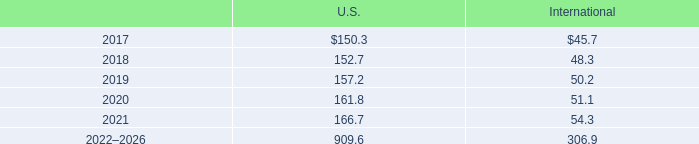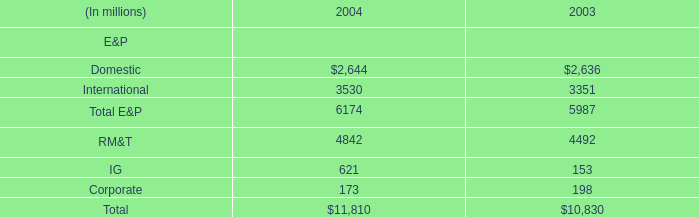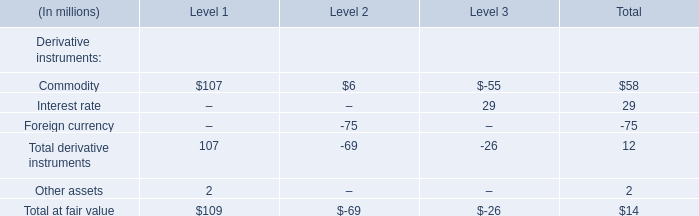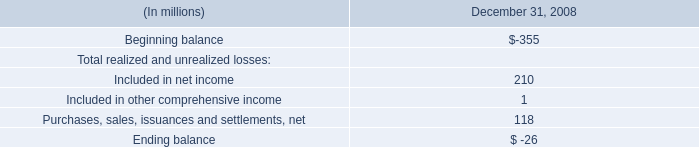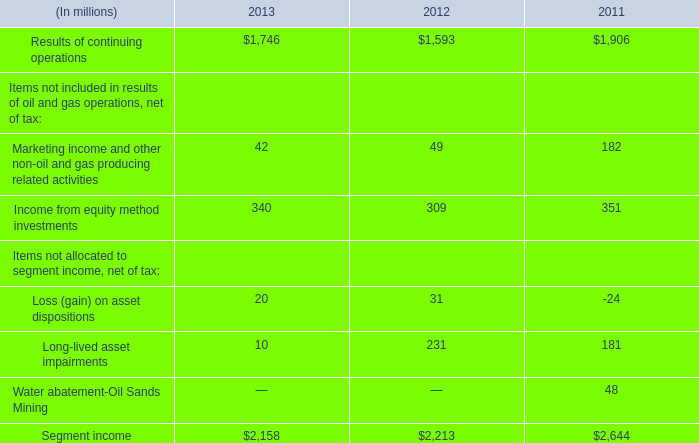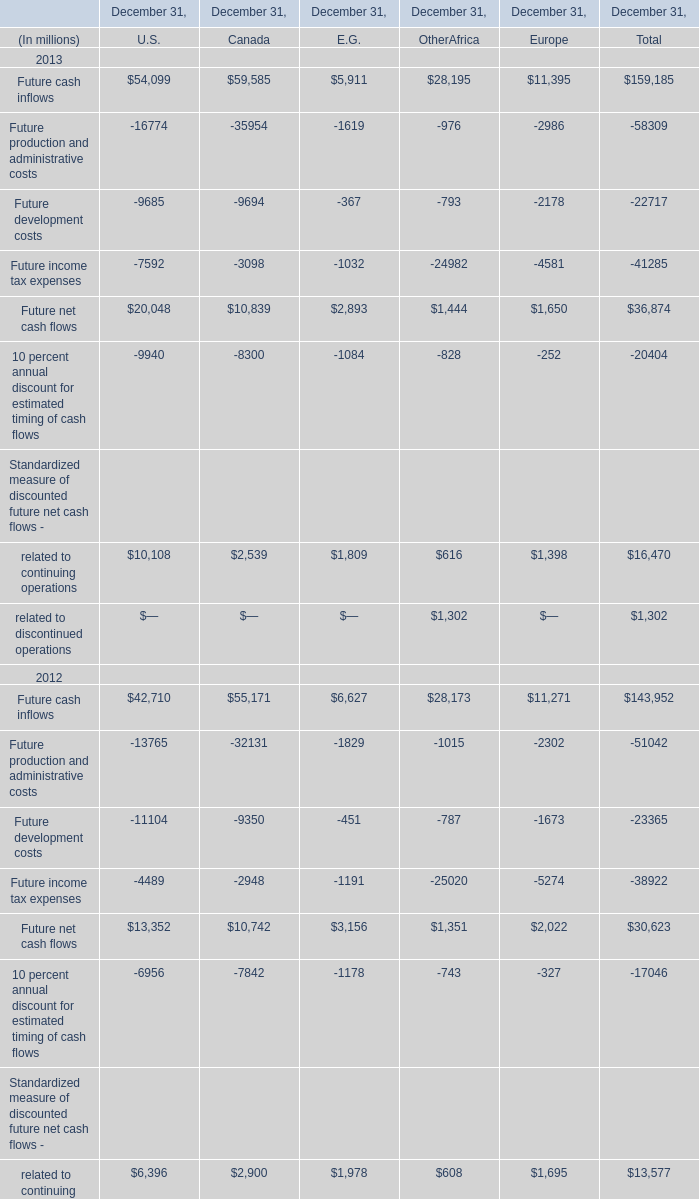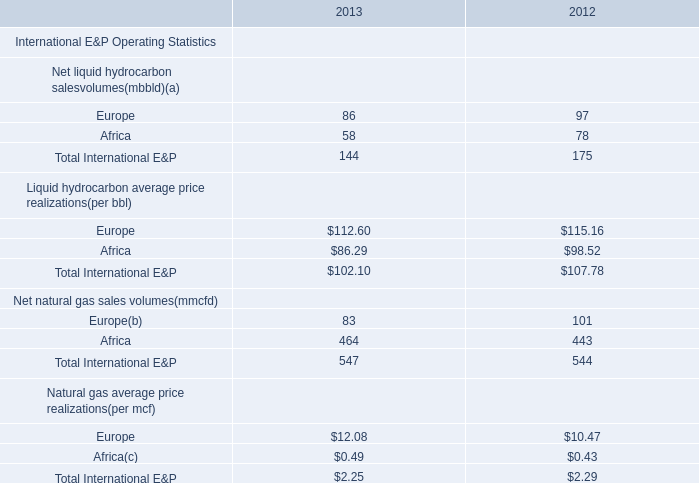what's the total amount of Future production and administrative costs of December 31, Europe, and Results of continuing operations of 2012 ? 
Computations: (2986.0 + 1593.0)
Answer: 4579.0. 